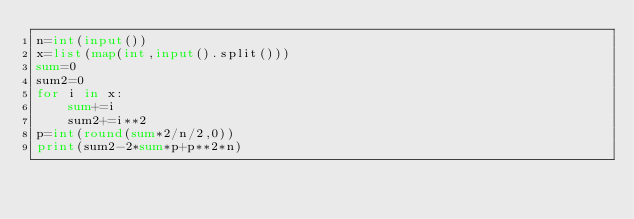Convert code to text. <code><loc_0><loc_0><loc_500><loc_500><_Python_>n=int(input())
x=list(map(int,input().split()))
sum=0
sum2=0
for i in x:
    sum+=i
    sum2+=i**2
p=int(round(sum*2/n/2,0))
print(sum2-2*sum*p+p**2*n)</code> 